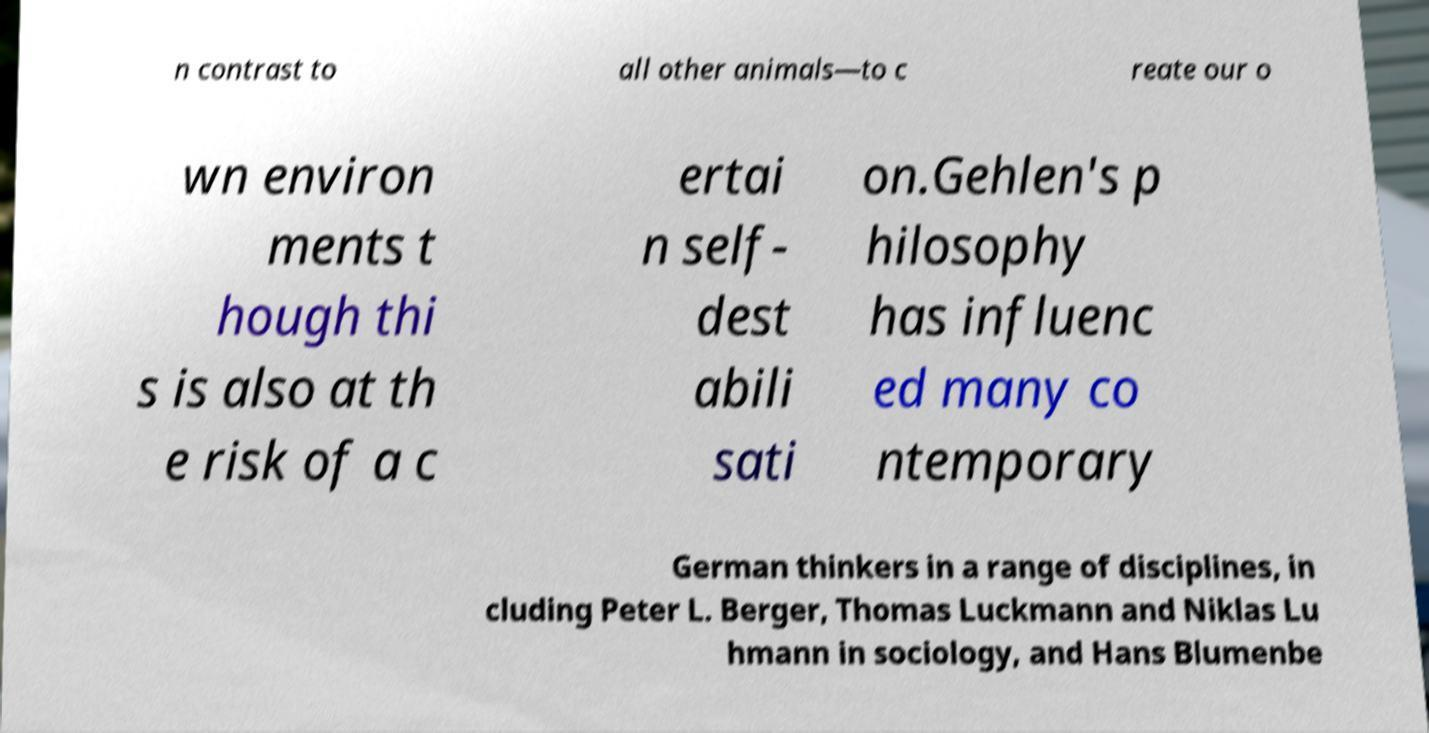Please read and relay the text visible in this image. What does it say? n contrast to all other animals—to c reate our o wn environ ments t hough thi s is also at th e risk of a c ertai n self- dest abili sati on.Gehlen's p hilosophy has influenc ed many co ntemporary German thinkers in a range of disciplines, in cluding Peter L. Berger, Thomas Luckmann and Niklas Lu hmann in sociology, and Hans Blumenbe 